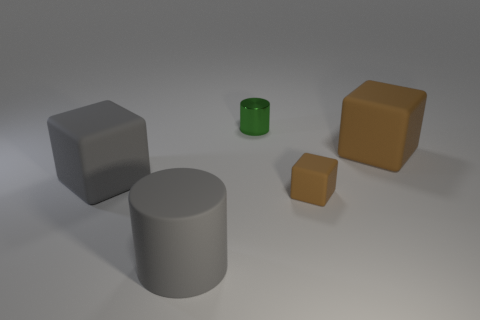Subtract all large brown rubber cubes. How many cubes are left? 2 Add 2 big cylinders. How many objects exist? 7 Subtract all gray blocks. How many blocks are left? 2 Subtract all blocks. How many objects are left? 2 Subtract 0 purple blocks. How many objects are left? 5 Subtract 3 blocks. How many blocks are left? 0 Subtract all red cylinders. Subtract all gray balls. How many cylinders are left? 2 Subtract all brown cylinders. How many gray cubes are left? 1 Subtract all big cyan balls. Subtract all large gray cylinders. How many objects are left? 4 Add 5 tiny blocks. How many tiny blocks are left? 6 